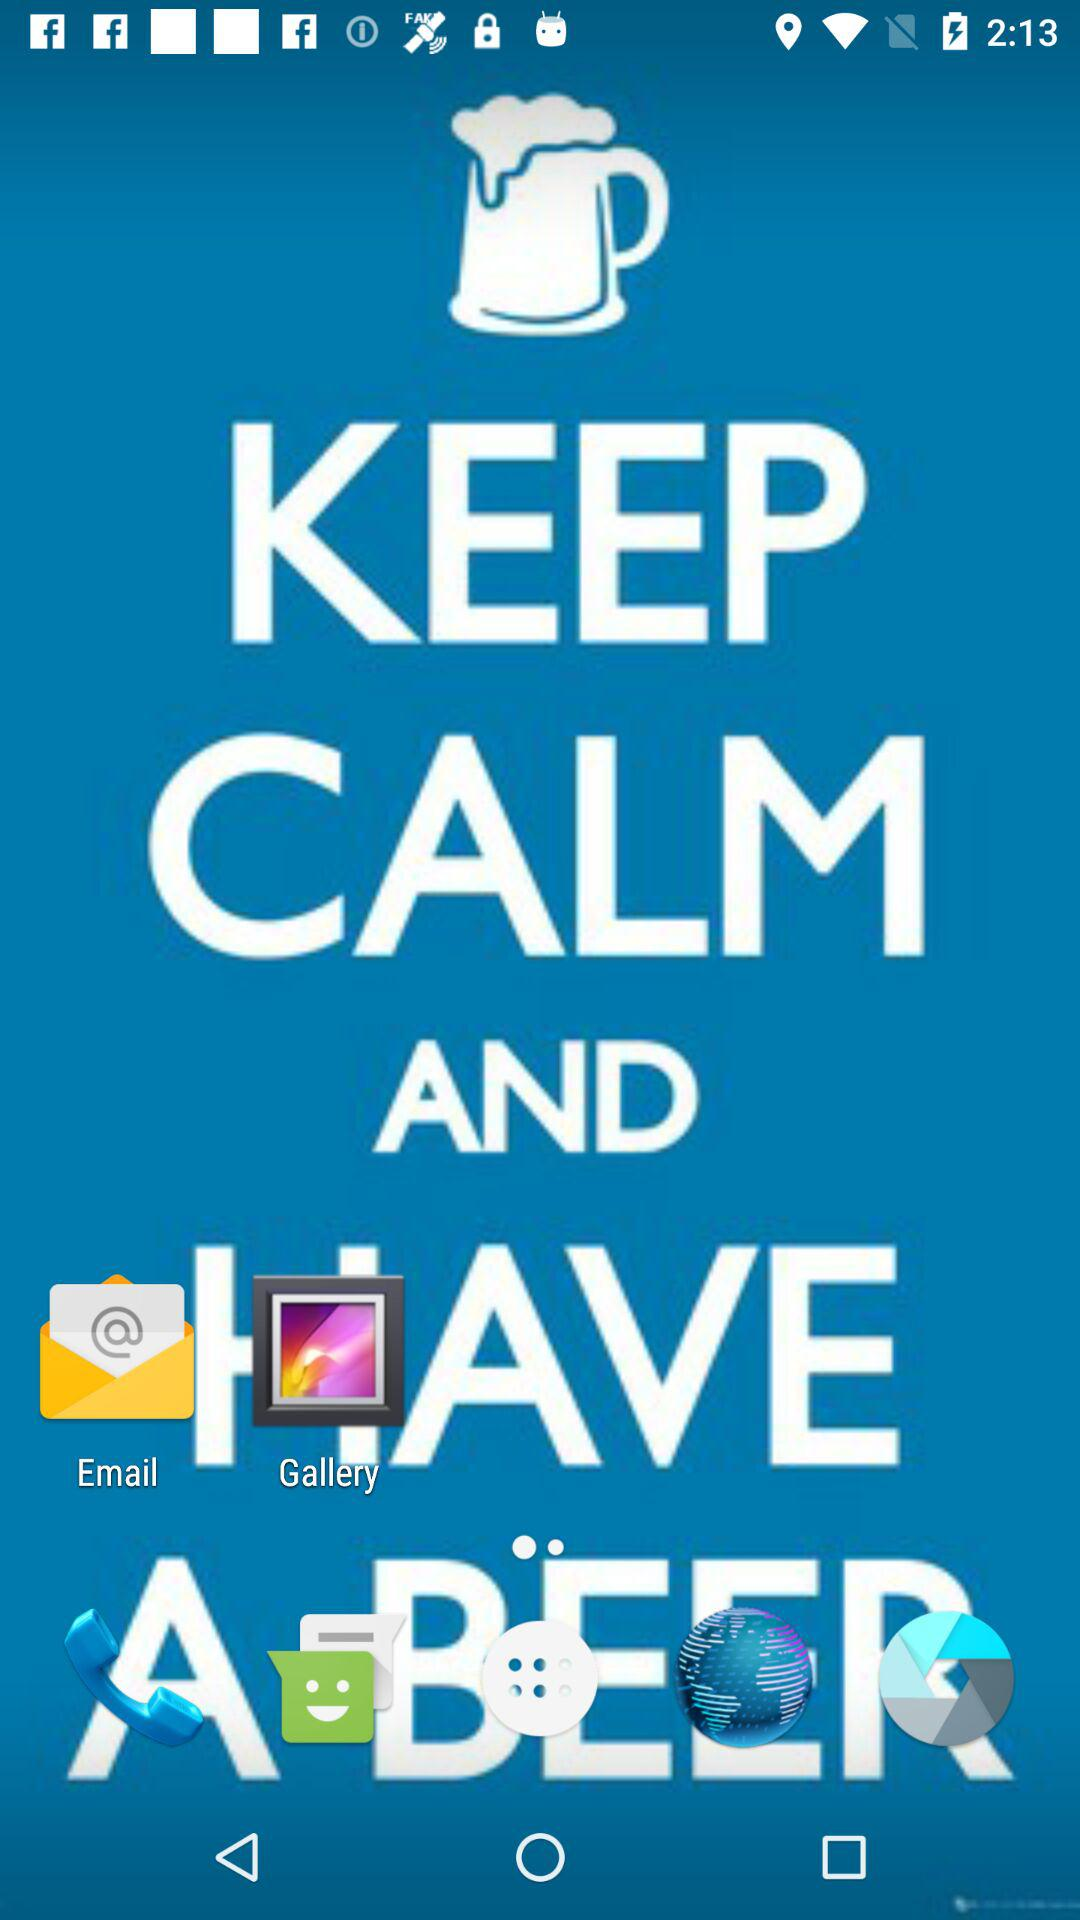Which option is selected? The selected option is "NEW". 